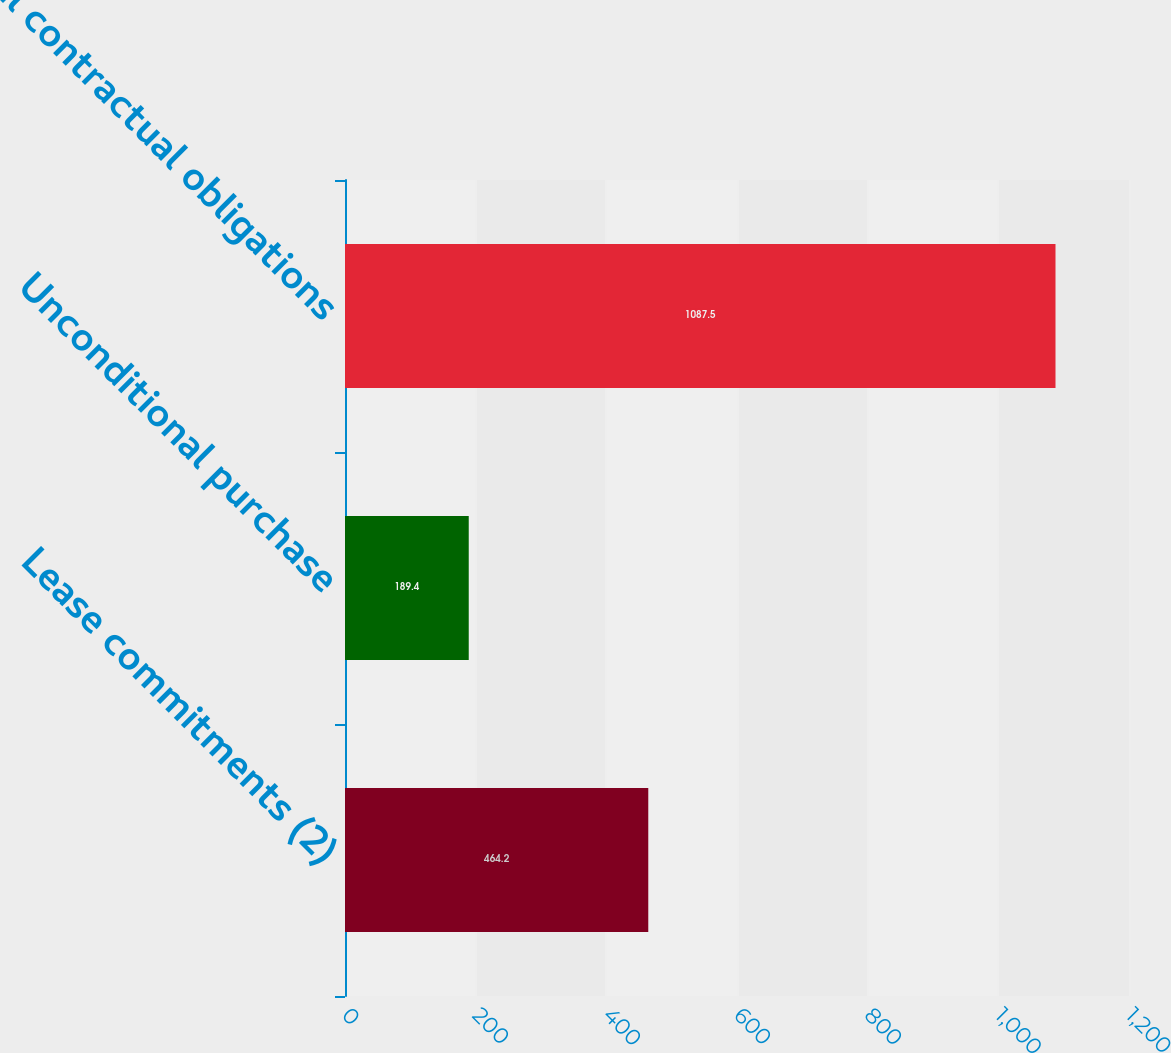Convert chart to OTSL. <chart><loc_0><loc_0><loc_500><loc_500><bar_chart><fcel>Lease commitments (2)<fcel>Unconditional purchase<fcel>Total contractual obligations<nl><fcel>464.2<fcel>189.4<fcel>1087.5<nl></chart> 